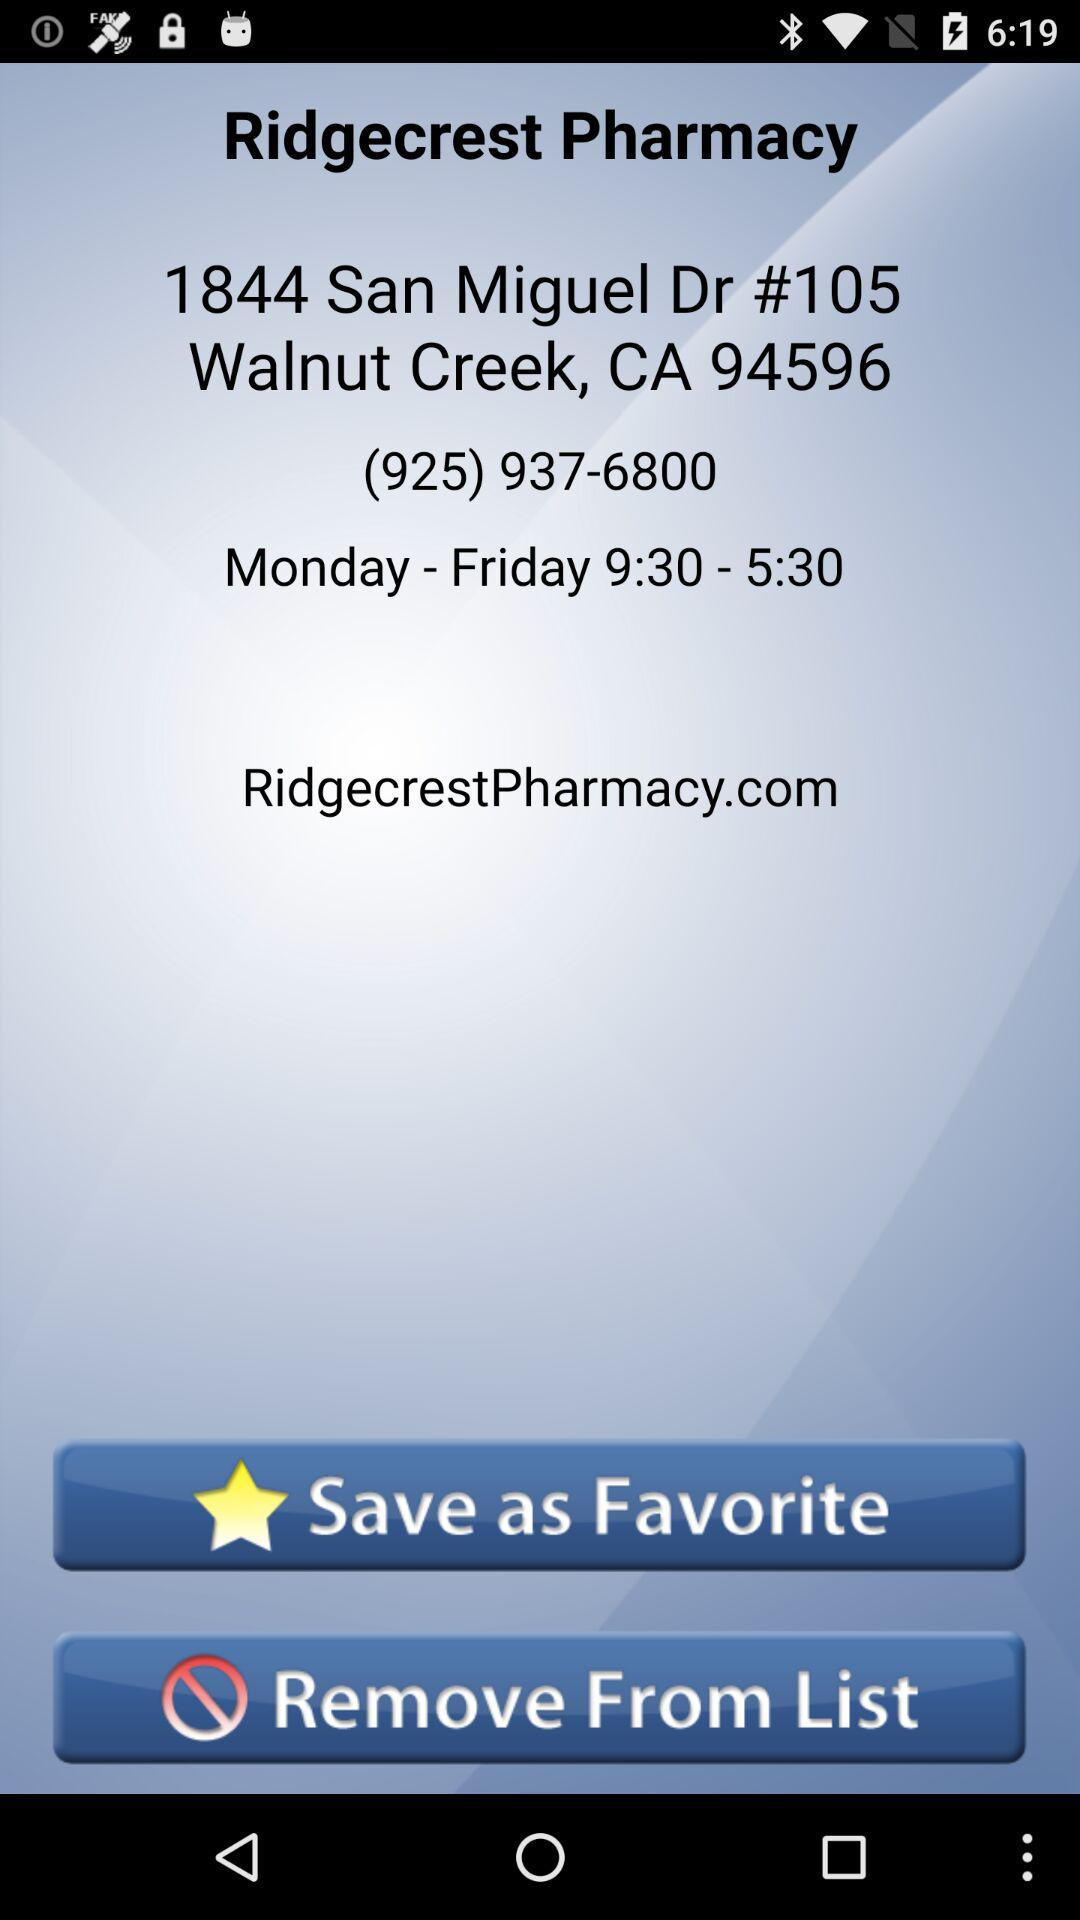What is the contact number given for "Ridgecrest Pharmacy"? The contact number given for "Ridgecrest Pharmacy" is (925) 937-6800. 